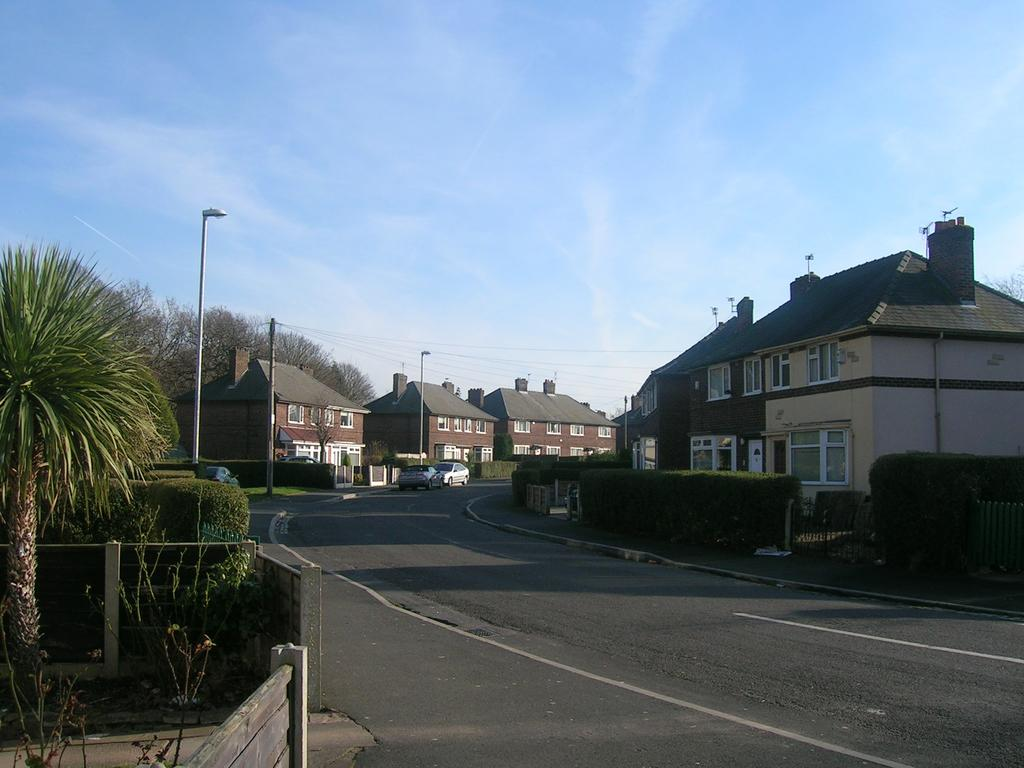How many vehicles can be seen on the road in the image? There are two vehicles on the road in the image. What can be seen in the background of the image? The sky, clouds, trees, plants, fences, poles, buildings, windows, and a few other objects are visible in the background of the image. What type of game is being played by the vehicles in the image? There is no game being played by the vehicles in the image; they are simply driving on the road. What taste does the image have? The image does not have a taste, as it is a visual representation and not a food item. 